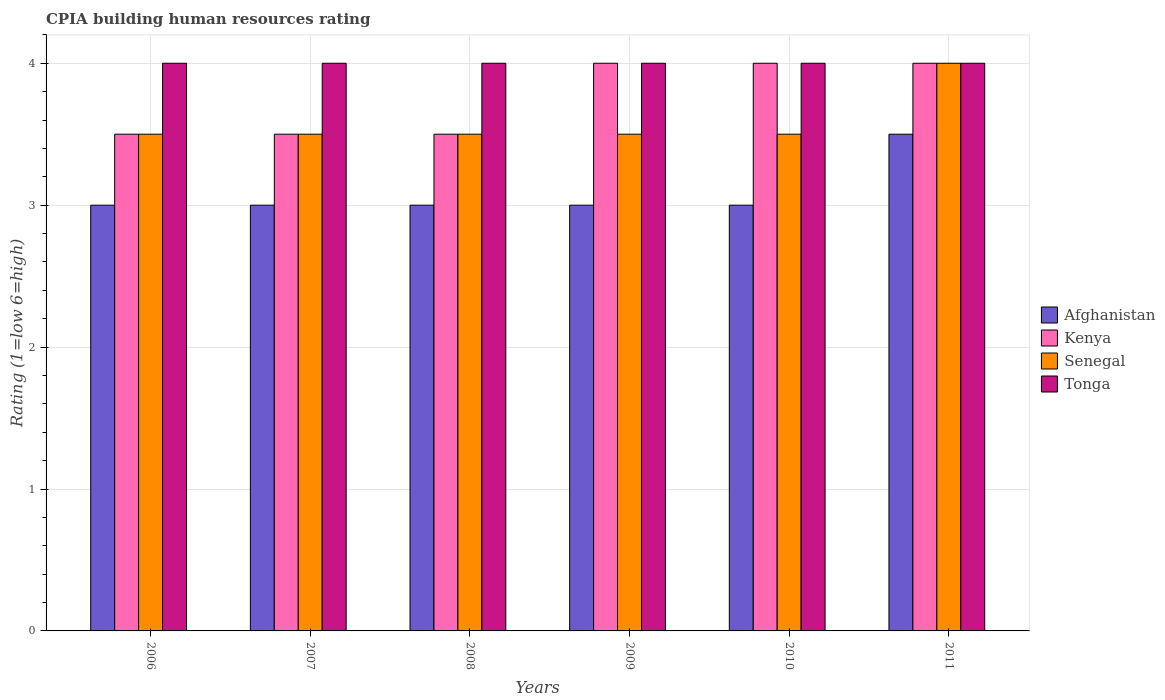Are the number of bars per tick equal to the number of legend labels?
Make the answer very short. Yes. What is the label of the 5th group of bars from the left?
Your answer should be compact. 2010. Across all years, what is the maximum CPIA rating in Afghanistan?
Provide a succinct answer. 3.5. Across all years, what is the minimum CPIA rating in Senegal?
Ensure brevity in your answer.  3.5. What is the average CPIA rating in Kenya per year?
Provide a short and direct response. 3.75. Is the difference between the CPIA rating in Senegal in 2010 and 2011 greater than the difference between the CPIA rating in Afghanistan in 2010 and 2011?
Your response must be concise. No. What is the difference between the highest and the lowest CPIA rating in Kenya?
Provide a succinct answer. 0.5. What does the 1st bar from the left in 2009 represents?
Provide a short and direct response. Afghanistan. What does the 1st bar from the right in 2009 represents?
Your answer should be very brief. Tonga. Is it the case that in every year, the sum of the CPIA rating in Tonga and CPIA rating in Senegal is greater than the CPIA rating in Kenya?
Make the answer very short. Yes. How many bars are there?
Your answer should be very brief. 24. Are all the bars in the graph horizontal?
Your response must be concise. No. How many years are there in the graph?
Make the answer very short. 6. Does the graph contain any zero values?
Offer a terse response. No. Does the graph contain grids?
Offer a terse response. Yes. What is the title of the graph?
Ensure brevity in your answer.  CPIA building human resources rating. What is the label or title of the X-axis?
Give a very brief answer. Years. What is the label or title of the Y-axis?
Give a very brief answer. Rating (1=low 6=high). What is the Rating (1=low 6=high) of Afghanistan in 2006?
Offer a terse response. 3. What is the Rating (1=low 6=high) of Afghanistan in 2007?
Provide a short and direct response. 3. What is the Rating (1=low 6=high) of Senegal in 2007?
Your answer should be very brief. 3.5. What is the Rating (1=low 6=high) in Tonga in 2007?
Offer a very short reply. 4. What is the Rating (1=low 6=high) of Afghanistan in 2008?
Ensure brevity in your answer.  3. What is the Rating (1=low 6=high) in Kenya in 2008?
Keep it short and to the point. 3.5. What is the Rating (1=low 6=high) in Senegal in 2008?
Provide a short and direct response. 3.5. What is the Rating (1=low 6=high) in Tonga in 2010?
Your response must be concise. 4. Across all years, what is the maximum Rating (1=low 6=high) of Kenya?
Provide a succinct answer. 4. Across all years, what is the maximum Rating (1=low 6=high) of Senegal?
Provide a succinct answer. 4. Across all years, what is the maximum Rating (1=low 6=high) in Tonga?
Provide a succinct answer. 4. Across all years, what is the minimum Rating (1=low 6=high) of Kenya?
Ensure brevity in your answer.  3.5. Across all years, what is the minimum Rating (1=low 6=high) in Senegal?
Offer a very short reply. 3.5. Across all years, what is the minimum Rating (1=low 6=high) in Tonga?
Provide a short and direct response. 4. What is the total Rating (1=low 6=high) of Afghanistan in the graph?
Give a very brief answer. 18.5. What is the total Rating (1=low 6=high) of Kenya in the graph?
Provide a short and direct response. 22.5. What is the total Rating (1=low 6=high) in Senegal in the graph?
Give a very brief answer. 21.5. What is the difference between the Rating (1=low 6=high) of Senegal in 2006 and that in 2007?
Your answer should be very brief. 0. What is the difference between the Rating (1=low 6=high) of Afghanistan in 2006 and that in 2009?
Offer a very short reply. 0. What is the difference between the Rating (1=low 6=high) of Senegal in 2006 and that in 2009?
Your answer should be very brief. 0. What is the difference between the Rating (1=low 6=high) of Tonga in 2006 and that in 2009?
Offer a terse response. 0. What is the difference between the Rating (1=low 6=high) in Afghanistan in 2006 and that in 2010?
Ensure brevity in your answer.  0. What is the difference between the Rating (1=low 6=high) of Senegal in 2006 and that in 2010?
Your response must be concise. 0. What is the difference between the Rating (1=low 6=high) of Tonga in 2006 and that in 2010?
Give a very brief answer. 0. What is the difference between the Rating (1=low 6=high) of Afghanistan in 2006 and that in 2011?
Your answer should be compact. -0.5. What is the difference between the Rating (1=low 6=high) of Tonga in 2006 and that in 2011?
Give a very brief answer. 0. What is the difference between the Rating (1=low 6=high) of Afghanistan in 2007 and that in 2008?
Give a very brief answer. 0. What is the difference between the Rating (1=low 6=high) of Tonga in 2007 and that in 2008?
Provide a succinct answer. 0. What is the difference between the Rating (1=low 6=high) in Kenya in 2007 and that in 2009?
Ensure brevity in your answer.  -0.5. What is the difference between the Rating (1=low 6=high) of Tonga in 2007 and that in 2009?
Your answer should be compact. 0. What is the difference between the Rating (1=low 6=high) of Tonga in 2007 and that in 2010?
Your answer should be compact. 0. What is the difference between the Rating (1=low 6=high) in Kenya in 2007 and that in 2011?
Offer a very short reply. -0.5. What is the difference between the Rating (1=low 6=high) in Senegal in 2007 and that in 2011?
Offer a very short reply. -0.5. What is the difference between the Rating (1=low 6=high) of Tonga in 2007 and that in 2011?
Your response must be concise. 0. What is the difference between the Rating (1=low 6=high) in Afghanistan in 2008 and that in 2009?
Provide a short and direct response. 0. What is the difference between the Rating (1=low 6=high) in Senegal in 2008 and that in 2009?
Give a very brief answer. 0. What is the difference between the Rating (1=low 6=high) of Senegal in 2008 and that in 2010?
Keep it short and to the point. 0. What is the difference between the Rating (1=low 6=high) of Tonga in 2008 and that in 2010?
Provide a short and direct response. 0. What is the difference between the Rating (1=low 6=high) in Kenya in 2008 and that in 2011?
Offer a terse response. -0.5. What is the difference between the Rating (1=low 6=high) of Senegal in 2008 and that in 2011?
Provide a short and direct response. -0.5. What is the difference between the Rating (1=low 6=high) in Senegal in 2009 and that in 2010?
Your answer should be compact. 0. What is the difference between the Rating (1=low 6=high) of Senegal in 2009 and that in 2011?
Provide a succinct answer. -0.5. What is the difference between the Rating (1=low 6=high) of Kenya in 2010 and that in 2011?
Your response must be concise. 0. What is the difference between the Rating (1=low 6=high) in Tonga in 2010 and that in 2011?
Make the answer very short. 0. What is the difference between the Rating (1=low 6=high) of Afghanistan in 2006 and the Rating (1=low 6=high) of Senegal in 2007?
Keep it short and to the point. -0.5. What is the difference between the Rating (1=low 6=high) of Afghanistan in 2006 and the Rating (1=low 6=high) of Tonga in 2007?
Make the answer very short. -1. What is the difference between the Rating (1=low 6=high) in Kenya in 2006 and the Rating (1=low 6=high) in Senegal in 2007?
Provide a succinct answer. 0. What is the difference between the Rating (1=low 6=high) in Senegal in 2006 and the Rating (1=low 6=high) in Tonga in 2007?
Provide a succinct answer. -0.5. What is the difference between the Rating (1=low 6=high) in Afghanistan in 2006 and the Rating (1=low 6=high) in Kenya in 2008?
Provide a short and direct response. -0.5. What is the difference between the Rating (1=low 6=high) in Afghanistan in 2006 and the Rating (1=low 6=high) in Senegal in 2008?
Ensure brevity in your answer.  -0.5. What is the difference between the Rating (1=low 6=high) in Kenya in 2006 and the Rating (1=low 6=high) in Senegal in 2008?
Provide a succinct answer. 0. What is the difference between the Rating (1=low 6=high) in Kenya in 2006 and the Rating (1=low 6=high) in Tonga in 2008?
Ensure brevity in your answer.  -0.5. What is the difference between the Rating (1=low 6=high) in Senegal in 2006 and the Rating (1=low 6=high) in Tonga in 2008?
Provide a short and direct response. -0.5. What is the difference between the Rating (1=low 6=high) of Afghanistan in 2006 and the Rating (1=low 6=high) of Kenya in 2009?
Make the answer very short. -1. What is the difference between the Rating (1=low 6=high) of Afghanistan in 2006 and the Rating (1=low 6=high) of Senegal in 2009?
Ensure brevity in your answer.  -0.5. What is the difference between the Rating (1=low 6=high) of Kenya in 2006 and the Rating (1=low 6=high) of Senegal in 2009?
Make the answer very short. 0. What is the difference between the Rating (1=low 6=high) in Senegal in 2006 and the Rating (1=low 6=high) in Tonga in 2009?
Keep it short and to the point. -0.5. What is the difference between the Rating (1=low 6=high) in Afghanistan in 2006 and the Rating (1=low 6=high) in Kenya in 2010?
Offer a terse response. -1. What is the difference between the Rating (1=low 6=high) of Afghanistan in 2006 and the Rating (1=low 6=high) of Tonga in 2010?
Make the answer very short. -1. What is the difference between the Rating (1=low 6=high) in Kenya in 2006 and the Rating (1=low 6=high) in Tonga in 2010?
Your answer should be compact. -0.5. What is the difference between the Rating (1=low 6=high) of Senegal in 2006 and the Rating (1=low 6=high) of Tonga in 2011?
Make the answer very short. -0.5. What is the difference between the Rating (1=low 6=high) of Afghanistan in 2007 and the Rating (1=low 6=high) of Kenya in 2008?
Offer a very short reply. -0.5. What is the difference between the Rating (1=low 6=high) of Afghanistan in 2007 and the Rating (1=low 6=high) of Senegal in 2008?
Offer a terse response. -0.5. What is the difference between the Rating (1=low 6=high) in Senegal in 2007 and the Rating (1=low 6=high) in Tonga in 2008?
Provide a succinct answer. -0.5. What is the difference between the Rating (1=low 6=high) in Afghanistan in 2007 and the Rating (1=low 6=high) in Kenya in 2009?
Your answer should be very brief. -1. What is the difference between the Rating (1=low 6=high) in Kenya in 2007 and the Rating (1=low 6=high) in Tonga in 2009?
Your answer should be very brief. -0.5. What is the difference between the Rating (1=low 6=high) of Afghanistan in 2007 and the Rating (1=low 6=high) of Kenya in 2010?
Ensure brevity in your answer.  -1. What is the difference between the Rating (1=low 6=high) in Afghanistan in 2007 and the Rating (1=low 6=high) in Senegal in 2010?
Provide a succinct answer. -0.5. What is the difference between the Rating (1=low 6=high) of Senegal in 2007 and the Rating (1=low 6=high) of Tonga in 2010?
Your answer should be compact. -0.5. What is the difference between the Rating (1=low 6=high) of Afghanistan in 2007 and the Rating (1=low 6=high) of Kenya in 2011?
Your answer should be compact. -1. What is the difference between the Rating (1=low 6=high) in Afghanistan in 2007 and the Rating (1=low 6=high) in Senegal in 2011?
Make the answer very short. -1. What is the difference between the Rating (1=low 6=high) in Kenya in 2007 and the Rating (1=low 6=high) in Tonga in 2011?
Ensure brevity in your answer.  -0.5. What is the difference between the Rating (1=low 6=high) in Senegal in 2007 and the Rating (1=low 6=high) in Tonga in 2011?
Ensure brevity in your answer.  -0.5. What is the difference between the Rating (1=low 6=high) of Afghanistan in 2008 and the Rating (1=low 6=high) of Kenya in 2009?
Offer a terse response. -1. What is the difference between the Rating (1=low 6=high) in Afghanistan in 2008 and the Rating (1=low 6=high) in Tonga in 2009?
Offer a very short reply. -1. What is the difference between the Rating (1=low 6=high) in Senegal in 2008 and the Rating (1=low 6=high) in Tonga in 2009?
Make the answer very short. -0.5. What is the difference between the Rating (1=low 6=high) of Afghanistan in 2008 and the Rating (1=low 6=high) of Tonga in 2010?
Your answer should be very brief. -1. What is the difference between the Rating (1=low 6=high) of Kenya in 2008 and the Rating (1=low 6=high) of Senegal in 2010?
Your answer should be compact. 0. What is the difference between the Rating (1=low 6=high) of Kenya in 2008 and the Rating (1=low 6=high) of Tonga in 2010?
Keep it short and to the point. -0.5. What is the difference between the Rating (1=low 6=high) in Afghanistan in 2008 and the Rating (1=low 6=high) in Tonga in 2011?
Offer a very short reply. -1. What is the difference between the Rating (1=low 6=high) in Kenya in 2008 and the Rating (1=low 6=high) in Senegal in 2011?
Offer a terse response. -0.5. What is the difference between the Rating (1=low 6=high) of Kenya in 2008 and the Rating (1=low 6=high) of Tonga in 2011?
Your response must be concise. -0.5. What is the difference between the Rating (1=low 6=high) in Afghanistan in 2009 and the Rating (1=low 6=high) in Senegal in 2010?
Your response must be concise. -0.5. What is the difference between the Rating (1=low 6=high) in Senegal in 2009 and the Rating (1=low 6=high) in Tonga in 2010?
Your answer should be very brief. -0.5. What is the difference between the Rating (1=low 6=high) in Afghanistan in 2009 and the Rating (1=low 6=high) in Kenya in 2011?
Ensure brevity in your answer.  -1. What is the difference between the Rating (1=low 6=high) in Kenya in 2009 and the Rating (1=low 6=high) in Senegal in 2011?
Your response must be concise. 0. What is the difference between the Rating (1=low 6=high) in Kenya in 2009 and the Rating (1=low 6=high) in Tonga in 2011?
Your answer should be compact. 0. What is the difference between the Rating (1=low 6=high) of Afghanistan in 2010 and the Rating (1=low 6=high) of Senegal in 2011?
Offer a very short reply. -1. What is the difference between the Rating (1=low 6=high) of Afghanistan in 2010 and the Rating (1=low 6=high) of Tonga in 2011?
Your response must be concise. -1. What is the difference between the Rating (1=low 6=high) of Kenya in 2010 and the Rating (1=low 6=high) of Tonga in 2011?
Offer a terse response. 0. What is the average Rating (1=low 6=high) of Afghanistan per year?
Make the answer very short. 3.08. What is the average Rating (1=low 6=high) of Kenya per year?
Ensure brevity in your answer.  3.75. What is the average Rating (1=low 6=high) in Senegal per year?
Keep it short and to the point. 3.58. In the year 2006, what is the difference between the Rating (1=low 6=high) of Afghanistan and Rating (1=low 6=high) of Kenya?
Give a very brief answer. -0.5. In the year 2006, what is the difference between the Rating (1=low 6=high) in Kenya and Rating (1=low 6=high) in Senegal?
Provide a succinct answer. 0. In the year 2006, what is the difference between the Rating (1=low 6=high) of Kenya and Rating (1=low 6=high) of Tonga?
Your response must be concise. -0.5. In the year 2006, what is the difference between the Rating (1=low 6=high) of Senegal and Rating (1=low 6=high) of Tonga?
Provide a succinct answer. -0.5. In the year 2007, what is the difference between the Rating (1=low 6=high) in Afghanistan and Rating (1=low 6=high) in Kenya?
Keep it short and to the point. -0.5. In the year 2007, what is the difference between the Rating (1=low 6=high) in Afghanistan and Rating (1=low 6=high) in Tonga?
Provide a succinct answer. -1. In the year 2007, what is the difference between the Rating (1=low 6=high) in Kenya and Rating (1=low 6=high) in Senegal?
Ensure brevity in your answer.  0. In the year 2007, what is the difference between the Rating (1=low 6=high) of Senegal and Rating (1=low 6=high) of Tonga?
Offer a terse response. -0.5. In the year 2008, what is the difference between the Rating (1=low 6=high) of Afghanistan and Rating (1=low 6=high) of Kenya?
Offer a terse response. -0.5. In the year 2008, what is the difference between the Rating (1=low 6=high) of Afghanistan and Rating (1=low 6=high) of Senegal?
Offer a very short reply. -0.5. In the year 2008, what is the difference between the Rating (1=low 6=high) of Kenya and Rating (1=low 6=high) of Senegal?
Your answer should be compact. 0. In the year 2008, what is the difference between the Rating (1=low 6=high) in Kenya and Rating (1=low 6=high) in Tonga?
Make the answer very short. -0.5. In the year 2008, what is the difference between the Rating (1=low 6=high) of Senegal and Rating (1=low 6=high) of Tonga?
Ensure brevity in your answer.  -0.5. In the year 2009, what is the difference between the Rating (1=low 6=high) in Afghanistan and Rating (1=low 6=high) in Kenya?
Offer a very short reply. -1. In the year 2009, what is the difference between the Rating (1=low 6=high) of Kenya and Rating (1=low 6=high) of Senegal?
Keep it short and to the point. 0.5. In the year 2010, what is the difference between the Rating (1=low 6=high) in Afghanistan and Rating (1=low 6=high) in Kenya?
Give a very brief answer. -1. In the year 2010, what is the difference between the Rating (1=low 6=high) in Afghanistan and Rating (1=low 6=high) in Senegal?
Your response must be concise. -0.5. In the year 2010, what is the difference between the Rating (1=low 6=high) in Kenya and Rating (1=low 6=high) in Senegal?
Your response must be concise. 0.5. In the year 2010, what is the difference between the Rating (1=low 6=high) in Kenya and Rating (1=low 6=high) in Tonga?
Your answer should be compact. 0. In the year 2010, what is the difference between the Rating (1=low 6=high) of Senegal and Rating (1=low 6=high) of Tonga?
Your answer should be compact. -0.5. In the year 2011, what is the difference between the Rating (1=low 6=high) of Afghanistan and Rating (1=low 6=high) of Senegal?
Provide a short and direct response. -0.5. What is the ratio of the Rating (1=low 6=high) of Kenya in 2006 to that in 2007?
Make the answer very short. 1. What is the ratio of the Rating (1=low 6=high) in Senegal in 2006 to that in 2007?
Give a very brief answer. 1. What is the ratio of the Rating (1=low 6=high) in Kenya in 2006 to that in 2008?
Give a very brief answer. 1. What is the ratio of the Rating (1=low 6=high) in Senegal in 2006 to that in 2008?
Give a very brief answer. 1. What is the ratio of the Rating (1=low 6=high) of Senegal in 2006 to that in 2010?
Provide a short and direct response. 1. What is the ratio of the Rating (1=low 6=high) of Kenya in 2006 to that in 2011?
Give a very brief answer. 0.88. What is the ratio of the Rating (1=low 6=high) of Kenya in 2007 to that in 2008?
Give a very brief answer. 1. What is the ratio of the Rating (1=low 6=high) of Senegal in 2007 to that in 2008?
Ensure brevity in your answer.  1. What is the ratio of the Rating (1=low 6=high) of Tonga in 2007 to that in 2008?
Your answer should be compact. 1. What is the ratio of the Rating (1=low 6=high) of Kenya in 2007 to that in 2009?
Keep it short and to the point. 0.88. What is the ratio of the Rating (1=low 6=high) in Senegal in 2007 to that in 2009?
Your answer should be very brief. 1. What is the ratio of the Rating (1=low 6=high) of Kenya in 2007 to that in 2010?
Provide a succinct answer. 0.88. What is the ratio of the Rating (1=low 6=high) of Senegal in 2007 to that in 2010?
Make the answer very short. 1. What is the ratio of the Rating (1=low 6=high) of Tonga in 2007 to that in 2011?
Provide a succinct answer. 1. What is the ratio of the Rating (1=low 6=high) in Senegal in 2008 to that in 2009?
Offer a very short reply. 1. What is the ratio of the Rating (1=low 6=high) of Tonga in 2008 to that in 2009?
Your answer should be very brief. 1. What is the ratio of the Rating (1=low 6=high) of Senegal in 2008 to that in 2010?
Your answer should be very brief. 1. What is the ratio of the Rating (1=low 6=high) in Kenya in 2008 to that in 2011?
Your answer should be compact. 0.88. What is the ratio of the Rating (1=low 6=high) of Senegal in 2008 to that in 2011?
Offer a very short reply. 0.88. What is the ratio of the Rating (1=low 6=high) of Afghanistan in 2009 to that in 2010?
Your response must be concise. 1. What is the ratio of the Rating (1=low 6=high) of Kenya in 2009 to that in 2010?
Your answer should be compact. 1. What is the ratio of the Rating (1=low 6=high) in Tonga in 2009 to that in 2010?
Your answer should be very brief. 1. What is the ratio of the Rating (1=low 6=high) of Afghanistan in 2009 to that in 2011?
Give a very brief answer. 0.86. What is the ratio of the Rating (1=low 6=high) of Senegal in 2009 to that in 2011?
Provide a short and direct response. 0.88. What is the ratio of the Rating (1=low 6=high) in Tonga in 2009 to that in 2011?
Give a very brief answer. 1. What is the ratio of the Rating (1=low 6=high) of Afghanistan in 2010 to that in 2011?
Your response must be concise. 0.86. What is the ratio of the Rating (1=low 6=high) in Senegal in 2010 to that in 2011?
Your answer should be very brief. 0.88. What is the ratio of the Rating (1=low 6=high) in Tonga in 2010 to that in 2011?
Offer a very short reply. 1. What is the difference between the highest and the second highest Rating (1=low 6=high) in Afghanistan?
Provide a short and direct response. 0.5. 